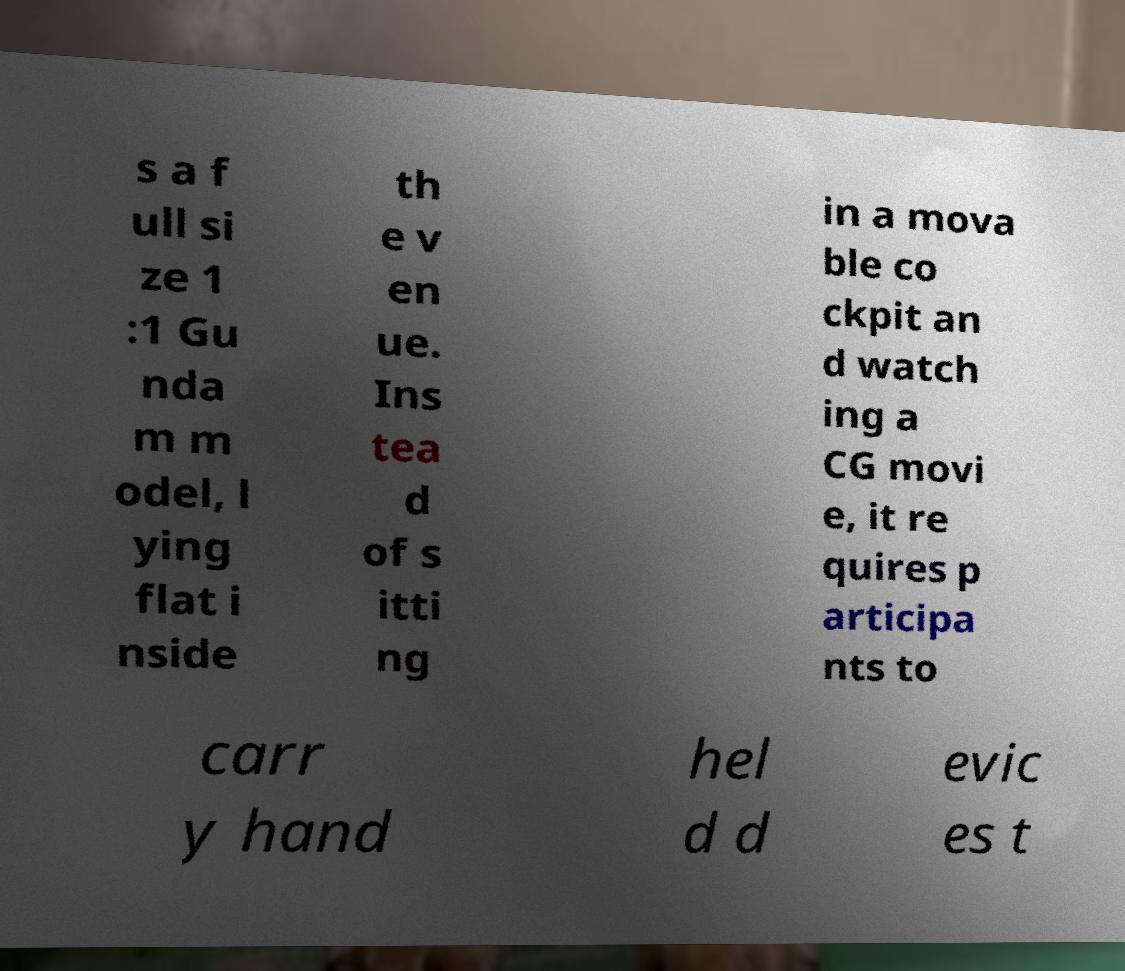Please identify and transcribe the text found in this image. s a f ull si ze 1 :1 Gu nda m m odel, l ying flat i nside th e v en ue. Ins tea d of s itti ng in a mova ble co ckpit an d watch ing a CG movi e, it re quires p articipa nts to carr y hand hel d d evic es t 